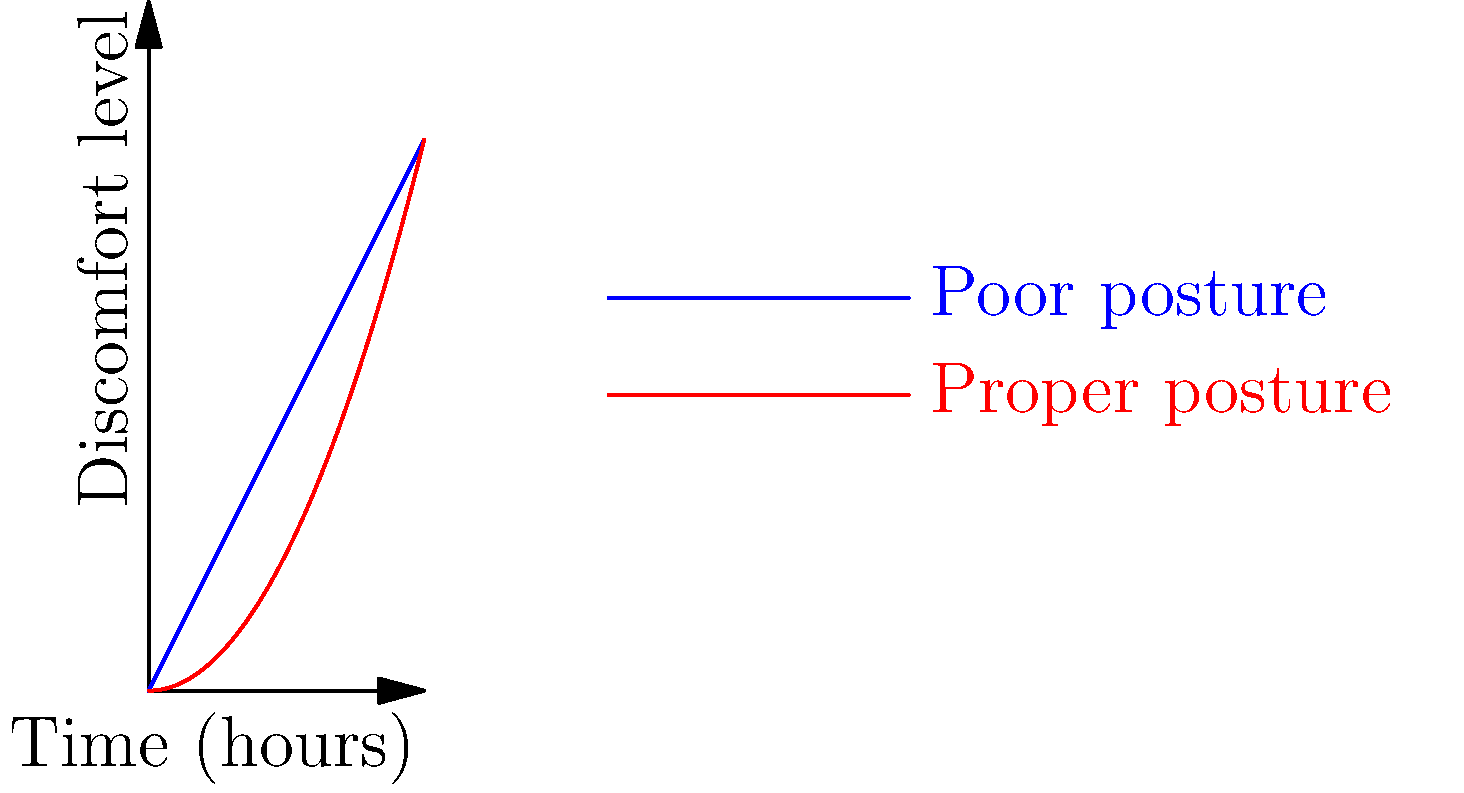The graph shows the relationship between time spent sitting and discomfort level for students during online learning sessions. The blue line represents poor posture, while the red line represents proper posture. After how many hours does the difference in discomfort level between poor and proper posture become greater than 5 units? To solve this problem, we need to follow these steps:

1. Understand the equations:
   - Poor posture (blue line): $y = 2x$
   - Proper posture (red line): $y = 0.5x^2$

2. Find the difference between the two equations:
   Difference = Poor posture - Proper posture
   $D = 2x - 0.5x^2$

3. Set up the inequality for when the difference becomes greater than 5:
   $2x - 0.5x^2 > 5$

4. Rearrange the inequality:
   $-0.5x^2 + 2x - 5 > 0$

5. Solve the quadratic inequality:
   a. Find the roots of the quadratic equation $-0.5x^2 + 2x - 5 = 0$
      Using the quadratic formula: $x = \frac{-b \pm \sqrt{b^2 - 4ac}}{2a}$
      $x = \frac{-2 \pm \sqrt{4 - 4(-0.5)(-5)}}{2(-0.5)} = \frac{-2 \pm \sqrt{14}}{-1}$
      $x_1 \approx 3.74$ and $x_2 \approx 0.26$

   b. The inequality is satisfied when $x > 3.74$ or $x < 0.26$

6. Since we're dealing with time, we can discard the negative solution.

Therefore, the difference in discomfort level between poor and proper posture becomes greater than 5 units after approximately 3.74 hours.
Answer: 3.74 hours 